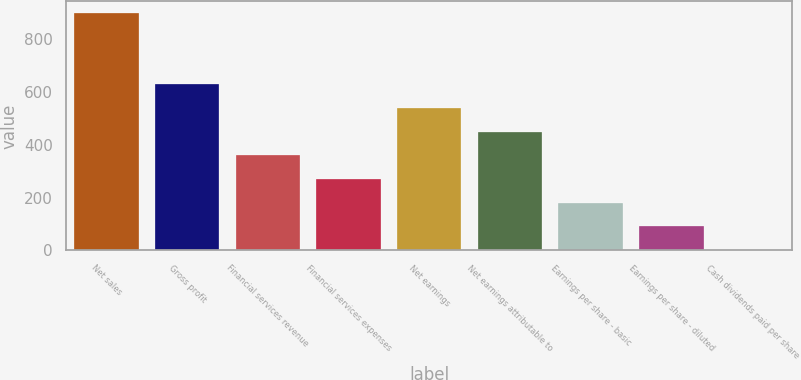Convert chart to OTSL. <chart><loc_0><loc_0><loc_500><loc_500><bar_chart><fcel>Net sales<fcel>Gross profit<fcel>Financial services revenue<fcel>Financial services expenses<fcel>Net earnings<fcel>Net earnings attributable to<fcel>Earnings per share - basic<fcel>Earnings per share - diluted<fcel>Cash dividends paid per share<nl><fcel>898.1<fcel>628.93<fcel>359.74<fcel>270.01<fcel>539.2<fcel>449.47<fcel>180.28<fcel>90.55<fcel>0.82<nl></chart> 